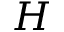Convert formula to latex. <formula><loc_0><loc_0><loc_500><loc_500>H</formula> 